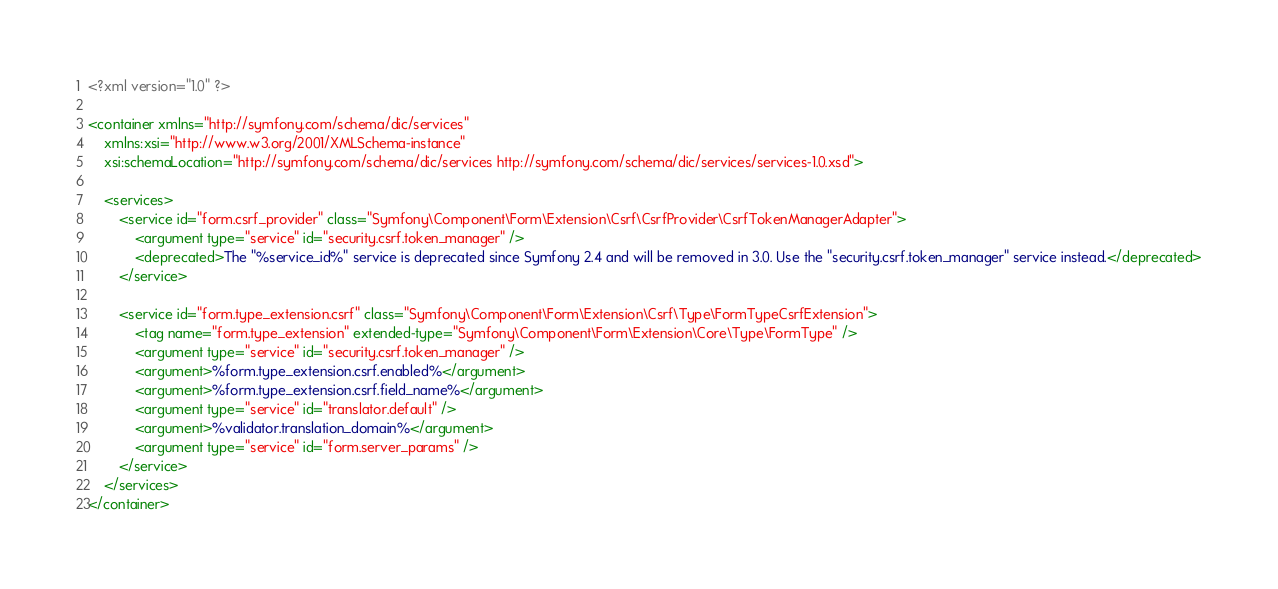Convert code to text. <code><loc_0><loc_0><loc_500><loc_500><_XML_><?xml version="1.0" ?>

<container xmlns="http://symfony.com/schema/dic/services"
    xmlns:xsi="http://www.w3.org/2001/XMLSchema-instance"
    xsi:schemaLocation="http://symfony.com/schema/dic/services http://symfony.com/schema/dic/services/services-1.0.xsd">

    <services>
        <service id="form.csrf_provider" class="Symfony\Component\Form\Extension\Csrf\CsrfProvider\CsrfTokenManagerAdapter">
            <argument type="service" id="security.csrf.token_manager" />
            <deprecated>The "%service_id%" service is deprecated since Symfony 2.4 and will be removed in 3.0. Use the "security.csrf.token_manager" service instead.</deprecated>
        </service>

        <service id="form.type_extension.csrf" class="Symfony\Component\Form\Extension\Csrf\Type\FormTypeCsrfExtension">
            <tag name="form.type_extension" extended-type="Symfony\Component\Form\Extension\Core\Type\FormType" />
            <argument type="service" id="security.csrf.token_manager" />
            <argument>%form.type_extension.csrf.enabled%</argument>
            <argument>%form.type_extension.csrf.field_name%</argument>
            <argument type="service" id="translator.default" />
            <argument>%validator.translation_domain%</argument>
            <argument type="service" id="form.server_params" />
        </service>
    </services>
</container>
</code> 